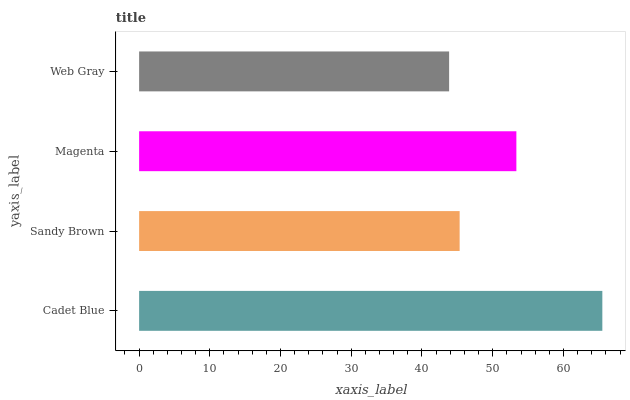Is Web Gray the minimum?
Answer yes or no. Yes. Is Cadet Blue the maximum?
Answer yes or no. Yes. Is Sandy Brown the minimum?
Answer yes or no. No. Is Sandy Brown the maximum?
Answer yes or no. No. Is Cadet Blue greater than Sandy Brown?
Answer yes or no. Yes. Is Sandy Brown less than Cadet Blue?
Answer yes or no. Yes. Is Sandy Brown greater than Cadet Blue?
Answer yes or no. No. Is Cadet Blue less than Sandy Brown?
Answer yes or no. No. Is Magenta the high median?
Answer yes or no. Yes. Is Sandy Brown the low median?
Answer yes or no. Yes. Is Cadet Blue the high median?
Answer yes or no. No. Is Web Gray the low median?
Answer yes or no. No. 